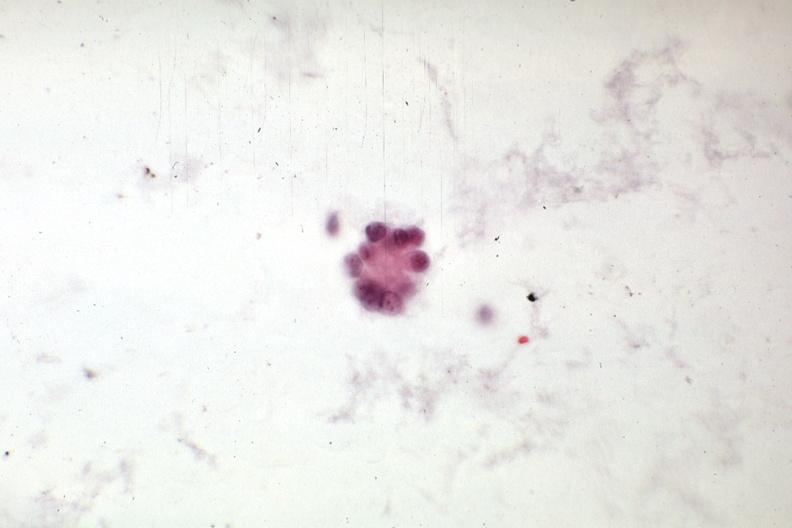s carcinoma present?
Answer the question using a single word or phrase. Yes 